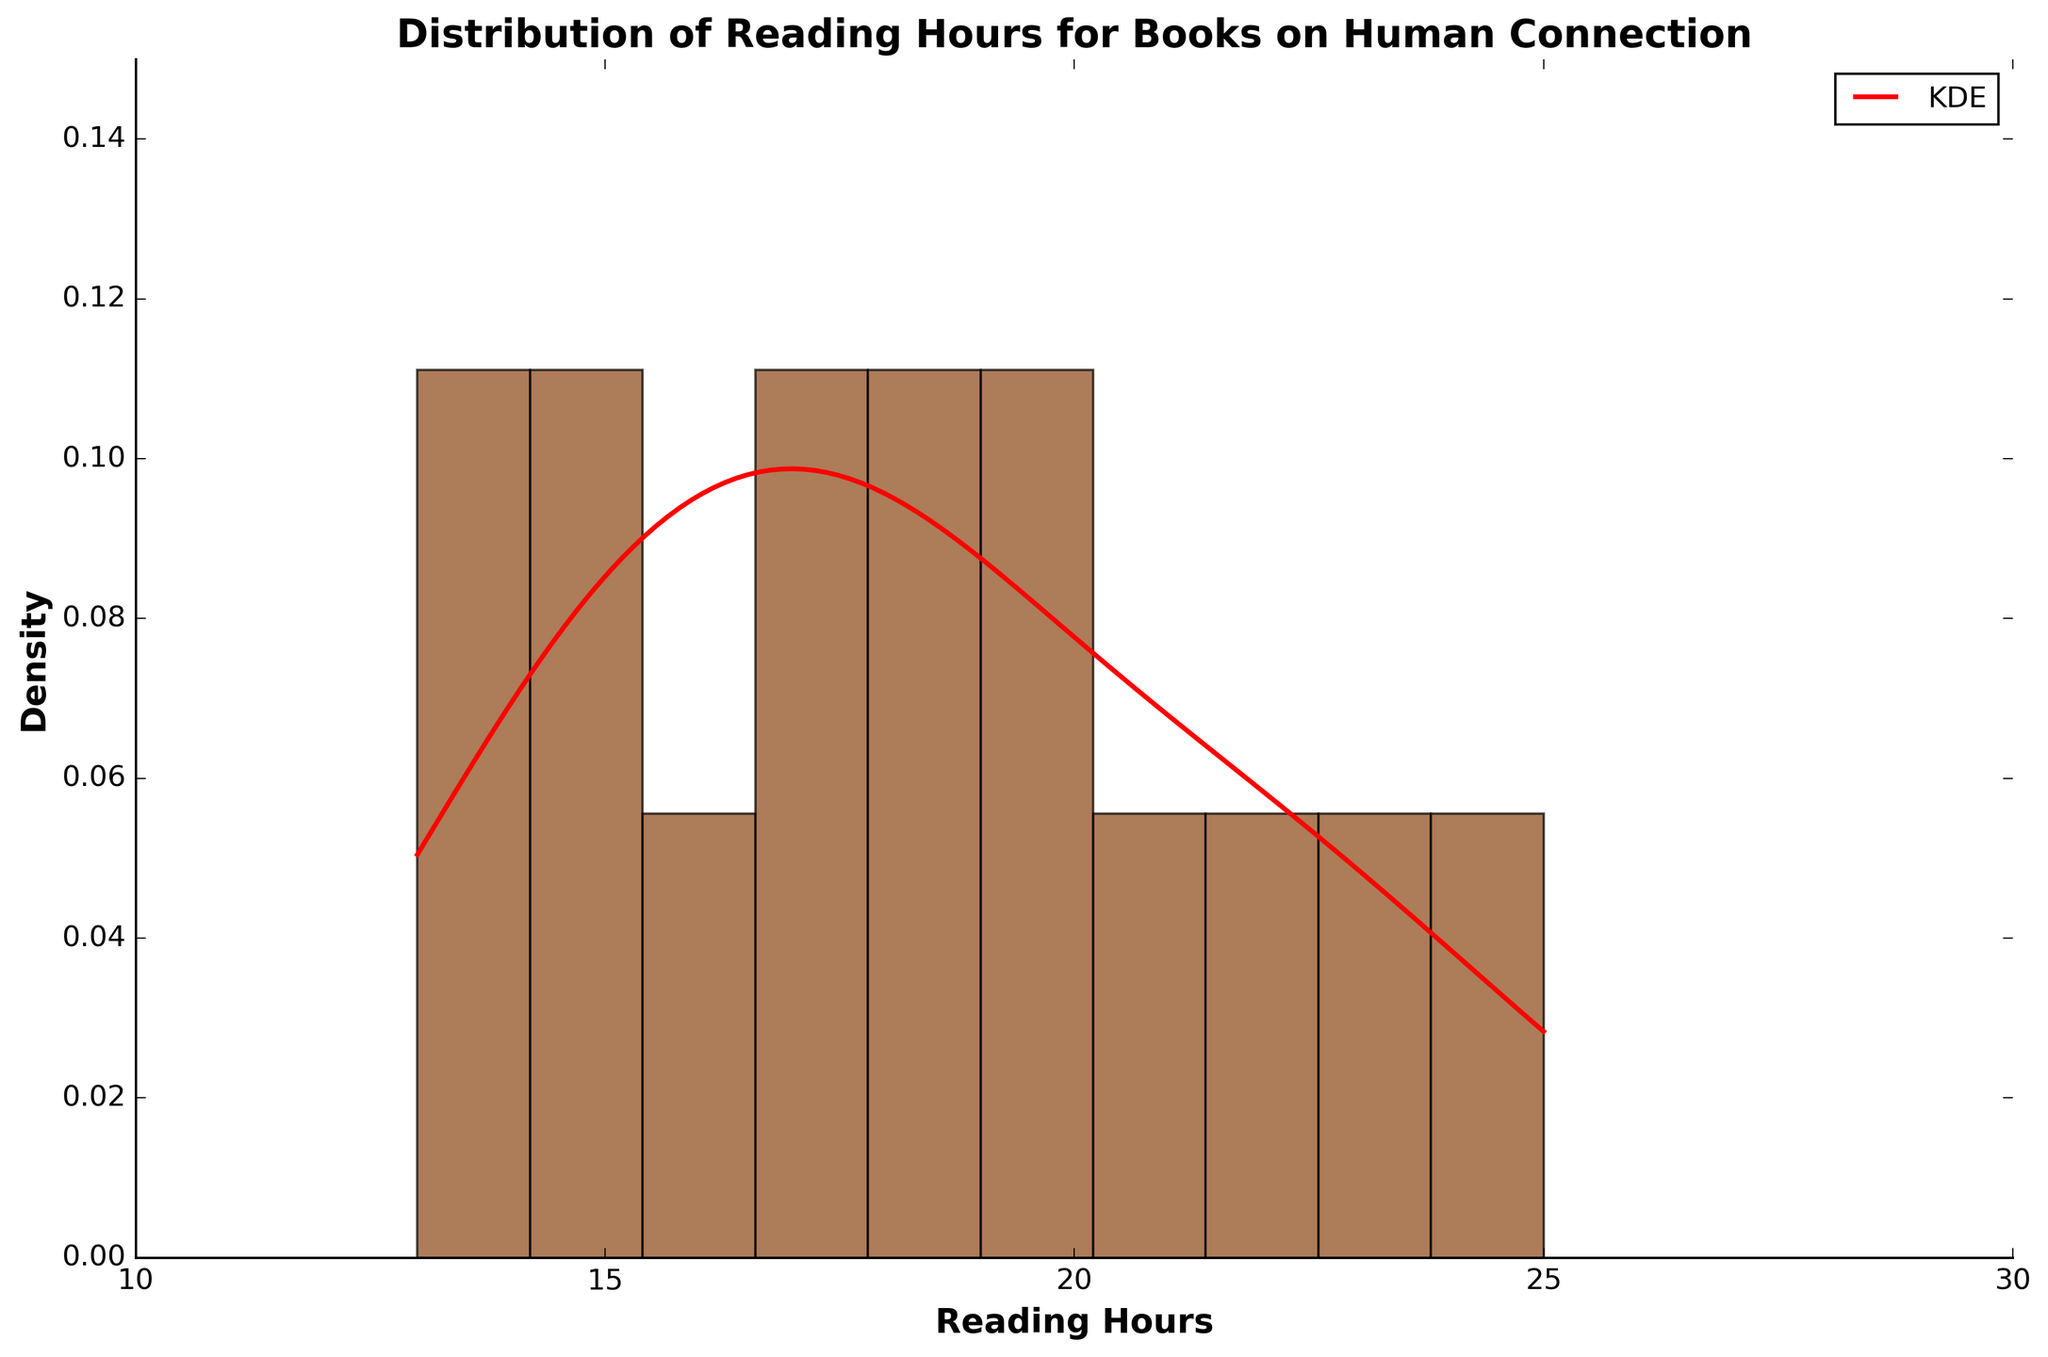What is the title of the figure? The title is written at the top of the figure. It states what the entire graph is about.
Answer: Distribution of Reading Hours for Books on Human Connection What does the x-axis represent in this histogram? The x-axis label provides information about what is being measured along the horizontal axis.
Answer: Reading Hours What is the color of the histogram bars? You can see the color of the histogram bars by looking at them visually.
Answer: Brown What's the maximum density shown on the y-axis? The y-axis scales up the highest density value presented in the figure, which you can find by looking at the upper boundary.
Answer: 0.15 Which reading hour range has the highest density of readings? Look for the highest histogram bar and then check the reading hours it covers.
Answer: 15 to 17 hours What's the median reading hour among the books listed? The median reading hour is the middle value when all values are sorted in ascending order. Count the values from both ends toward the middle.
Answer: 18 hours How many books have more than 20 reading hours? Look at the histogram bars and the corresponding ranges on the x-axis, count how many books fall into the ranges greater than 20 hours.
Answer: 4 books Is the KDE curve mostly increasing or decreasing in the range of 10 to 15 reading hours? Observe the shape of the KDE (density) curve from 10 to 15 reading hours to see if it generally goes up or down.
Answer: Increasing Between which two points does the KDE curve peak? Find the highest point on the KDE curve and identify the reading hour values on the x-axis for this peak.
Answer: 16 to 18 hours Are there more books with fewer or more than 18 reading hours? Compare the histogram bars lower than 18 to those higher than 18 to determine which side has more books.
Answer: Fewer 